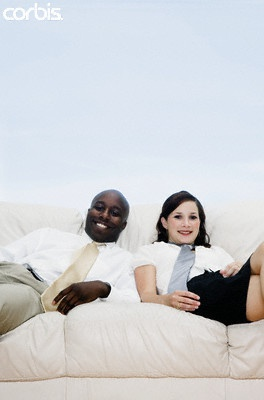Describe the objects in this image and their specific colors. I can see couch in lavender, lightgray, and darkgray tones, bed in lavender, lightgray, and darkgray tones, people in lavender, lightgray, darkgray, black, and gray tones, people in lavender, black, lightgray, tan, and darkgray tones, and tie in lavender, tan, and lightgray tones in this image. 